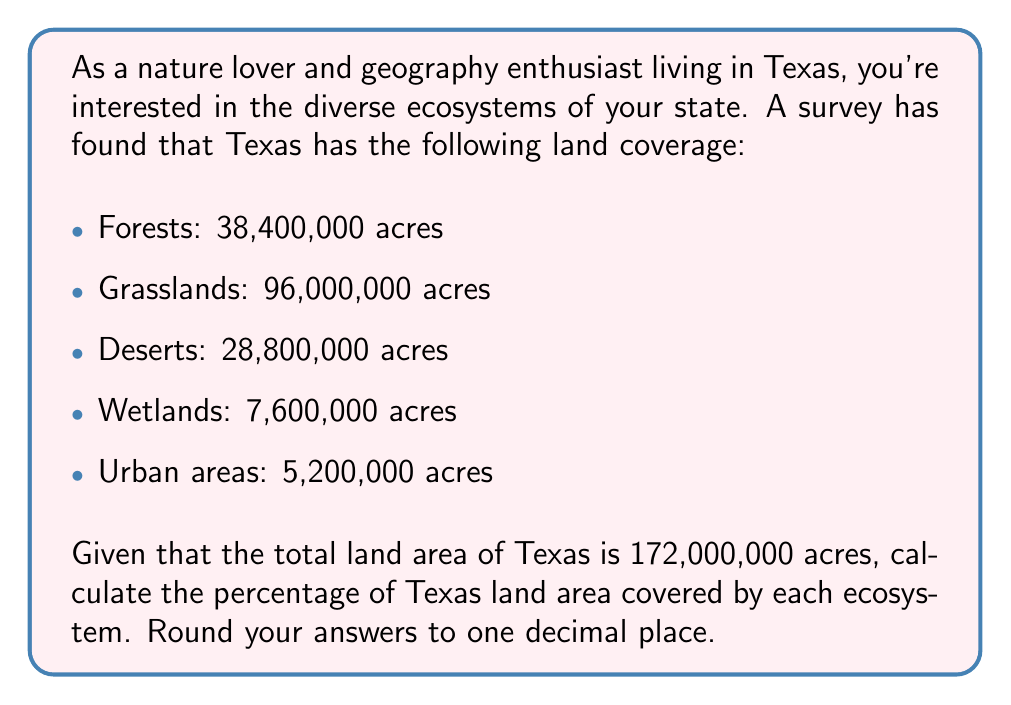Help me with this question. To calculate the percentage of Texas land area covered by each ecosystem, we need to divide the area of each ecosystem by the total land area of Texas and then multiply by 100. Let's go through this step-by-step:

1. Calculate the percentage for each ecosystem:

   Forests: 
   $$ \frac{38,400,000}{172,000,000} \times 100 = 22.3255\% $$

   Grasslands:
   $$ \frac{96,000,000}{172,000,000} \times 100 = 55.8140\% $$

   Deserts:
   $$ \frac{28,800,000}{172,000,000} \times 100 = 16.7442\% $$

   Wetlands:
   $$ \frac{7,600,000}{172,000,000} \times 100 = 4.4186\% $$

   Urban areas:
   $$ \frac{5,200,000}{172,000,000} \times 100 = 3.0233\% $$

2. Round each percentage to one decimal place:

   Forests: 22.3% ≈ 22.3%
   Grasslands: 55.8140% ≈ 55.8%
   Deserts: 16.7442% ≈ 16.7%
   Wetlands: 4.4186% ≈ 4.4%
   Urban areas: 3.0233% ≈ 3.0%

3. Verify that the percentages sum to approximately 100%:

   $22.3\% + 55.8\% + 16.7\% + 4.4\% + 3.0\% = 102.2\%$

   The slight discrepancy (102.2% instead of 100%) is due to rounding.
Answer: Forests: 22.3%
Grasslands: 55.8%
Deserts: 16.7%
Wetlands: 4.4%
Urban areas: 3.0% 